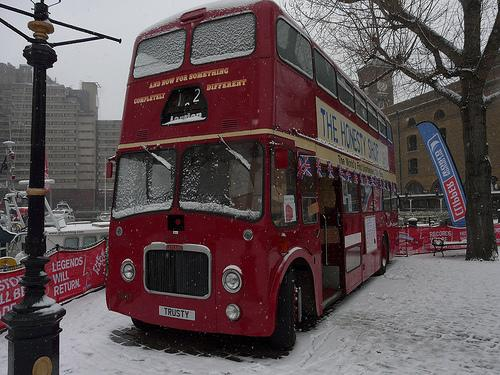Identify three different aspects of the bus that have been given specific attention in the captions. The bus's lights, snow on its windshield, and its small white sign have been given specific attention. List three objects in the vicinity of the bus, and describe one feature for each of them. There's a tree without leaves, a dark black and brass metal street post, and a wooden bench with snow on it. What is the status of the tree near the bus and what is its interaction with the environment? The tree near the bus has lost all of its leaves and stands bare. What is the condition of the ground where the bus is parked, and what evidence shows this? The ground is covered with snow, and there are footprints visible in it. What is written on the plate found on the bus, and what is its color? The plate on the bus reads "trusty" and it is white in color. Which vehicle in the image has a visible sign mentioning legends, and what is the exact phrase? The bus has a sign saying "legends will return." What is the dominant color of the bus and how many decks does it have? The bus is red and is a double-decker. Provide a brief description of the front part of the bus, including the windshield, lights, and sign. The front of the bus has snow on the windshield and wipers, round headlights, and a small white sign that says "trusty." How many headlights does the front part of the bus have, and what is their shape? The bus has three headlights which are round in shape. Describe a theme depicted on the side of the bus. The side of the bus has British flags and a small British flag printed on it. Describe the appearance of the tires on the bus. The tires are black and appear large in size. Is there a green tree with full leaves beside the bus? The tree beside the bus has lost all of its leaves, so mentioning it as green and full with leaves is incorrect. Describe the window layout of the bus in the image. The bus has multiple windows on both levels, and a large front windshield. Give a concise description of the image. A red British double-decker bus with snow on its windshield, standing near a tree and a black and gold lamp post. Provide a creative description of the image. A vintage red double-decker bus, wearing a coat of snow like a mantle, stands regally in a quiet winter wonderland, illuminated by the soft glow of a black and gold lamp post. What type of tree is near the vehicle? A tree that has lost all of its leaves. Which country's flag is shown on the side of the bus? British Does the sign on the bus say "The Dishonesty Store"? The sign on the bus actually says "The Honesty Shop," so mentioning a different name is not accurate. What is the bus doing in the image? The bus is parked or stationary in a snowy setting. Is the bus blue with a number 5 on it? The bus is actually red and has the number 2 on it, so mentioning a blue color and a different number is misleading. What color is the bus in the image? Red What shape are the bus lights? Round What does the small white sign on the front of the bus say? Trusty Provide an understanding of the bus's structure in the image. The bus is a double-decker with a large front windshield, multiple windows on both levels, round headlights, and a front plate that says "Trusty." Is there a black and silver lamp post on the left side of the bus? The lamp post is actually black and gold and is present at the front-right side of the bus, so mentioning different colors and position is misleading. Is there any snow on the ground? If so, describe it. Yes, there is snow on the ground, and footprints are visible. In a poetic manner, describe the scene with the bus. Amidst a snowy scene, a red double-decker stands tall, a symbol of British pride, with flags displayed and snowflakes kissing its windshield. Create a multi-modal description of the scene. In a snowy atmosphere, a majestic red double-decker bus proudly displays the British flag, basking in the serenity and beauty of its wintry surroundings.  What is the message on the yellow sign on the side of the bus? The Honesty Shop Capture the emotional tone of the image. A quaint, peaceful winter scene with a red double-decker bus. Are the bus's headlights square and small? The headlights on the bus are round and large, so describing them as square and small gives a wrong impression of their shape and size. Identify an event in the image. A red double-decker bus parked in a snowy location. Are there no footprints in the snow around the bus?  No, it's not mentioned in the image. 